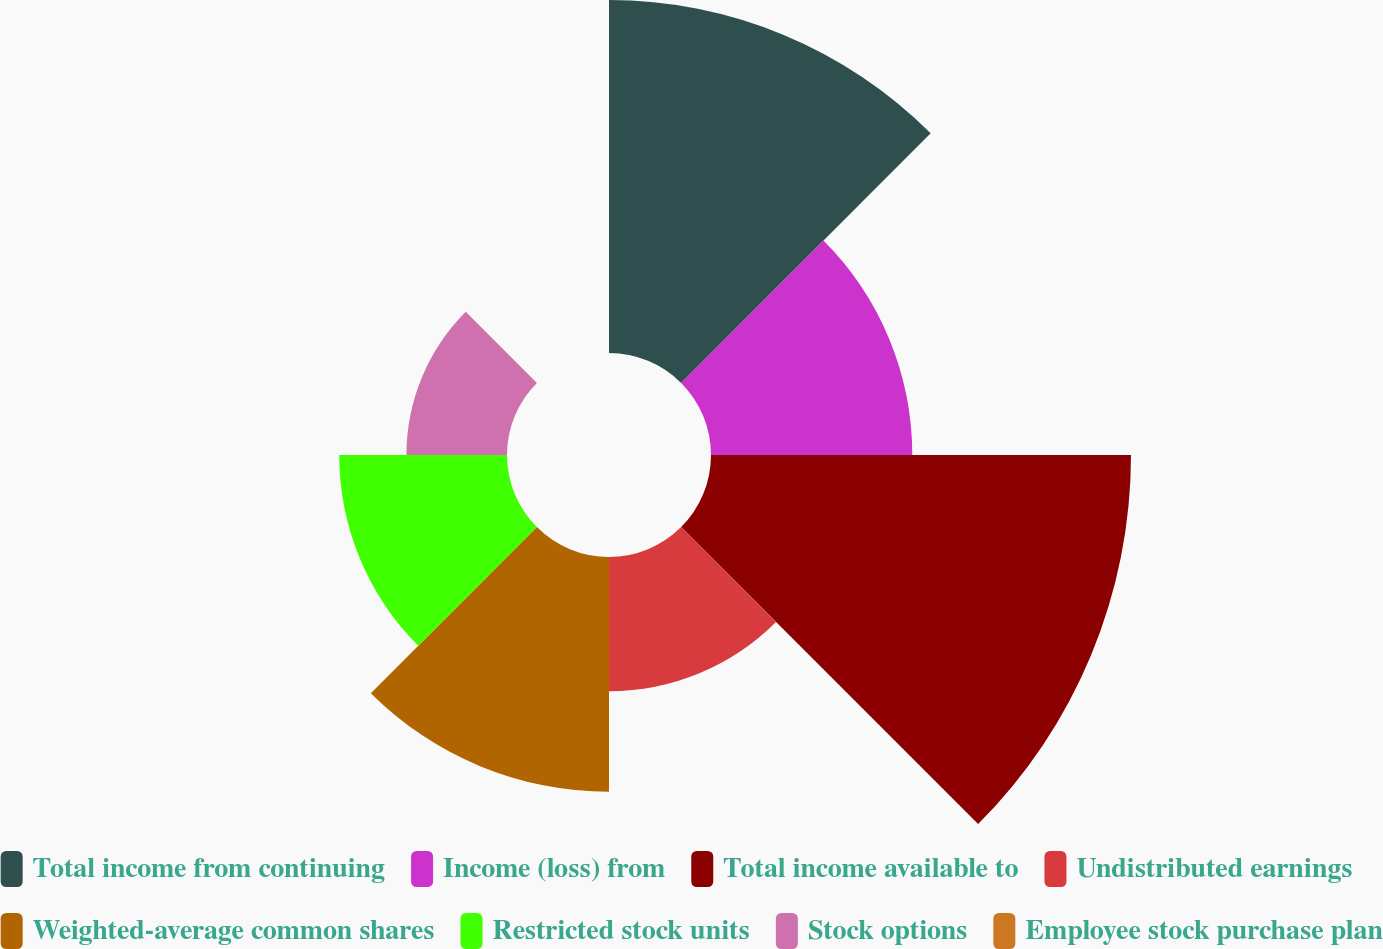Convert chart to OTSL. <chart><loc_0><loc_0><loc_500><loc_500><pie_chart><fcel>Total income from continuing<fcel>Income (loss) from<fcel>Total income available to<fcel>Undistributed earnings<fcel>Weighted-average common shares<fcel>Restricted stock units<fcel>Stock options<fcel>Employee stock purchase plan<nl><fcel>21.9%<fcel>12.49%<fcel>26.06%<fcel>8.33%<fcel>14.57%<fcel>10.41%<fcel>6.24%<fcel>0.0%<nl></chart> 